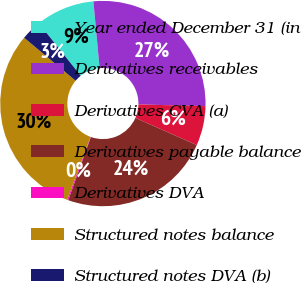<chart> <loc_0><loc_0><loc_500><loc_500><pie_chart><fcel>Year ended December 31 (in<fcel>Derivatives receivables<fcel>Derivatives CVA (a)<fcel>Derivatives payable balance<fcel>Derivatives DVA<fcel>Structured notes balance<fcel>Structured notes DVA (b)<nl><fcel>9.25%<fcel>26.87%<fcel>6.23%<fcel>23.85%<fcel>0.18%<fcel>30.42%<fcel>3.2%<nl></chart> 